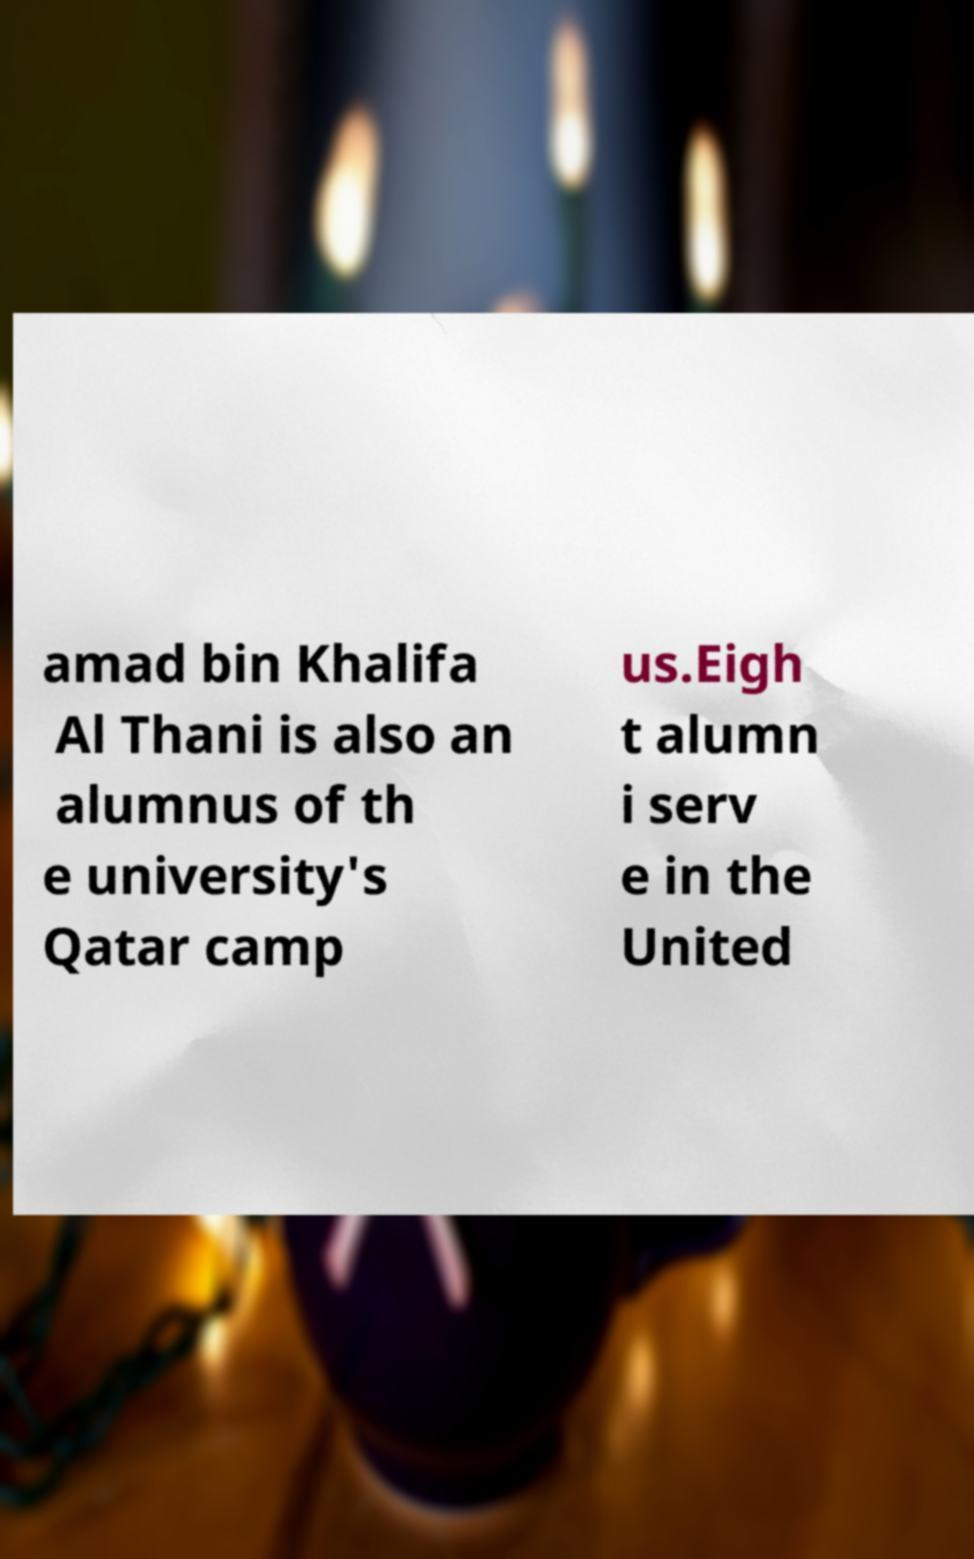Can you accurately transcribe the text from the provided image for me? amad bin Khalifa Al Thani is also an alumnus of th e university's Qatar camp us.Eigh t alumn i serv e in the United 